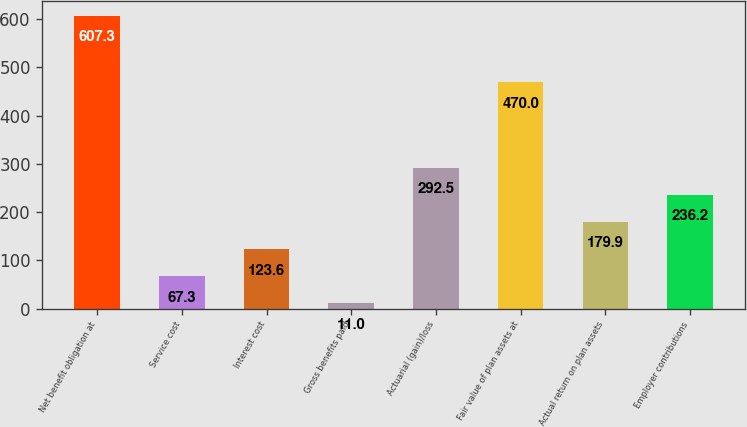Convert chart. <chart><loc_0><loc_0><loc_500><loc_500><bar_chart><fcel>Net benefit obligation at<fcel>Service cost<fcel>Interest cost<fcel>Gross benefits paid<fcel>Actuarial (gain)/loss<fcel>Fair value of plan assets at<fcel>Actual return on plan assets<fcel>Employer contributions<nl><fcel>607.3<fcel>67.3<fcel>123.6<fcel>11<fcel>292.5<fcel>470<fcel>179.9<fcel>236.2<nl></chart> 